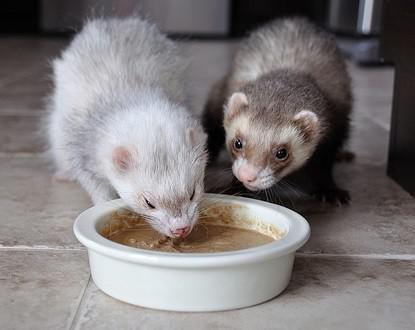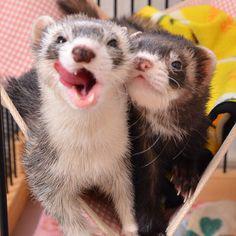The first image is the image on the left, the second image is the image on the right. For the images shown, is this caption "In one image, a little animal is facing forward with its mouth wide open and tongue showing, while a second image shows two similar animals in different colors." true? Answer yes or no. Yes. The first image is the image on the left, the second image is the image on the right. Given the left and right images, does the statement "A pair of ferrets are held side-by-side in a pair of human hands." hold true? Answer yes or no. No. 